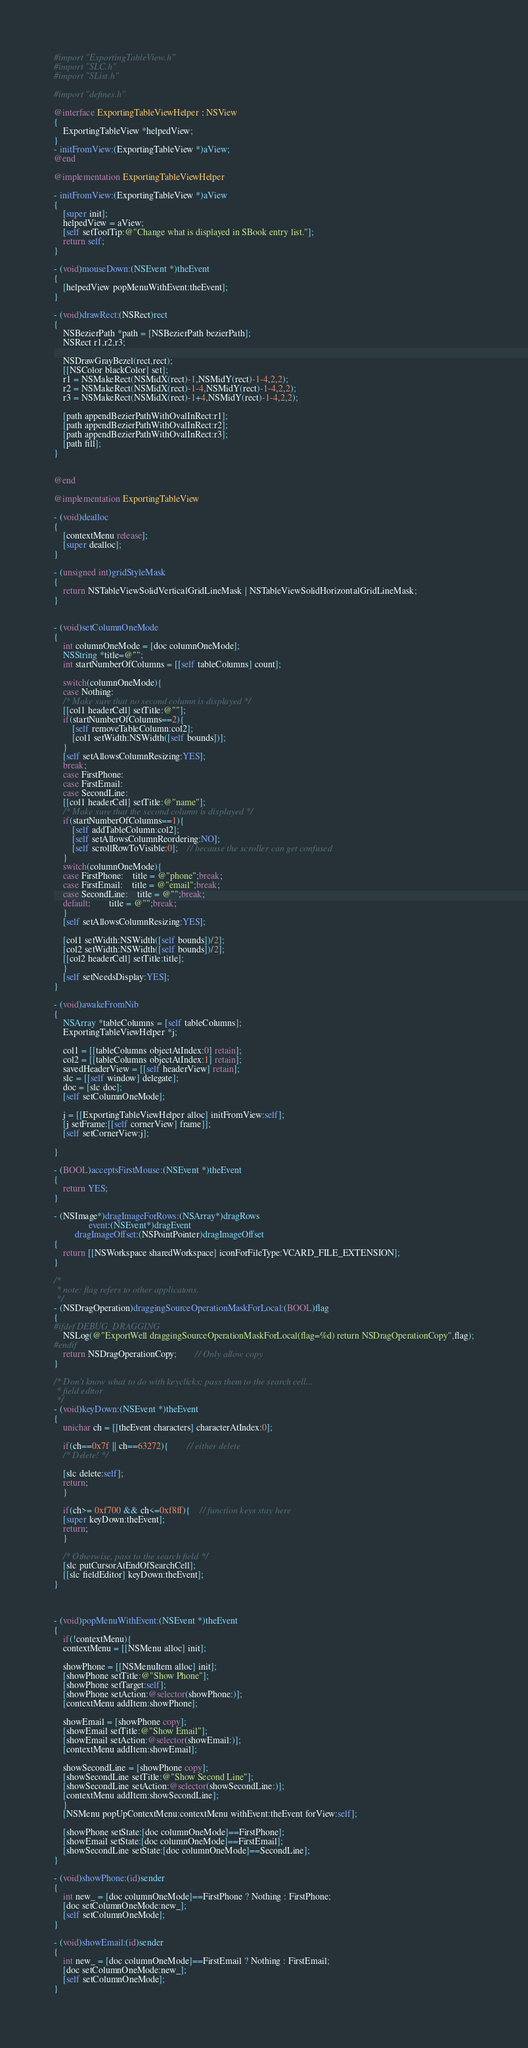<code> <loc_0><loc_0><loc_500><loc_500><_ObjectiveC_>
#import "ExportingTableView.h"
#import "SLC.h"
#import "SList.h"

#import "defines.h"

@interface ExportingTableViewHelper : NSView
{
    ExportingTableView *helpedView;
}
- initFromView:(ExportingTableView *)aView;
@end

@implementation ExportingTableViewHelper

- initFromView:(ExportingTableView *)aView
{
    [super init];
    helpedView = aView;
    [self setToolTip:@"Change what is displayed in SBook entry list."];
    return self;
}

- (void)mouseDown:(NSEvent *)theEvent
{
    [helpedView popMenuWithEvent:theEvent];
}

- (void)drawRect:(NSRect)rect
{
    NSBezierPath *path = [NSBezierPath bezierPath];
    NSRect r1,r2,r3;

    NSDrawGrayBezel(rect,rect);
    [[NSColor blackColor] set];
    r1 = NSMakeRect(NSMidX(rect)-1,NSMidY(rect)-1-4,2,2);
    r2 = NSMakeRect(NSMidX(rect)-1-4,NSMidY(rect)-1-4,2,2);
    r3 = NSMakeRect(NSMidX(rect)-1+4,NSMidY(rect)-1-4,2,2);

    [path appendBezierPathWithOvalInRect:r1];
    [path appendBezierPathWithOvalInRect:r2];
    [path appendBezierPathWithOvalInRect:r3];
    [path fill];
}


@end

@implementation ExportingTableView

- (void)dealloc
{
    [contextMenu release];
    [super dealloc];
}

- (unsigned int)gridStyleMask
{
    return NSTableViewSolidVerticalGridLineMask | NSTableViewSolidHorizontalGridLineMask;
}


- (void)setColumnOneMode
{
    int columnOneMode = [doc columnOneMode];
    NSString *title=@"";
    int startNumberOfColumns = [[self tableColumns] count];

    switch(columnOneMode){
    case Nothing:
	/* Make sure that no second column is displayed */
	[[col1 headerCell] setTitle:@""];
	if(startNumberOfColumns==2){
	    [self removeTableColumn:col2];
	    [col1 setWidth:NSWidth([self bounds])];
	}
	[self setAllowsColumnResizing:YES];
	break;
    case FirstPhone:
    case FirstEmail:
    case SecondLine:
	[[col1 headerCell] setTitle:@"name"];
	/* Make sure that the second column is displayed */
	if(startNumberOfColumns==1){
	    [self addTableColumn:col2];
	    [self setAllowsColumnReordering:NO];
	    [self scrollRowToVisible:0];	// because the scroller can get confused
	}
	switch(columnOneMode){
	case FirstPhone:	title = @"phone";break;
	case FirstEmail:	title = @"email";break;
	case SecondLine:	title = @"";break;
	default:		title = @"";break;
	}
	[self setAllowsColumnResizing:YES];

	[col1 setWidth:NSWidth([self bounds])/2];
	[col2 setWidth:NSWidth([self bounds])/2];
	[[col2 headerCell] setTitle:title];
    }
    [self setNeedsDisplay:YES];
}

- (void)awakeFromNib
{
    NSArray *tableColumns = [self tableColumns];
    ExportingTableViewHelper *j;

    col1 = [[tableColumns objectAtIndex:0] retain];
    col2 = [[tableColumns objectAtIndex:1] retain]; 
    savedHeaderView = [[self headerView] retain];
    slc = [[self window] delegate];
    doc = [slc doc];
    [self setColumnOneMode];

    j = [[ExportingTableViewHelper alloc] initFromView:self];
    [j setFrame:[[self cornerView] frame]];
    [self setCornerView:j];

}

- (BOOL)acceptsFirstMouse:(NSEvent *)theEvent
{
    return YES;
}

- (NSImage*)dragImageForRows:(NSArray*)dragRows
		       event:(NSEvent*)dragEvent
	     dragImageOffset:(NSPointPointer)dragImageOffset
{
    return [[NSWorkspace sharedWorkspace] iconForFileType:VCARD_FILE_EXTENSION];
}

/*
 * note: flag refers to other applicatons.
 */
- (NSDragOperation)draggingSourceOperationMaskForLocal:(BOOL)flag
{
#ifdef DEBUG_DRAGGING
    NSLog(@"ExportWell draggingSourceOperationMaskForLocal(flag=%d) return NSDragOperationCopy",flag);
#endif    
    return NSDragOperationCopy;		// Only allow copy
}

/* Don't know what to do with keyclicks; pass them to the search cell...
 * field editor
 */
- (void)keyDown:(NSEvent *)theEvent
{
    unichar ch = [[theEvent characters] characterAtIndex:0];

    if(ch==0x7f || ch==63272){		// either delete
	/* Delete! */
	
	[slc delete:self];
	return;
    }

    if(ch>= 0xf700 && ch<=0xf8ff){	// function keys stay here
	[super keyDown:theEvent];
	return;
    }

    /* Otherwise, pass to the search field */
    [slc putCursorAtEndOfSearchCell];
    [[slc fieldEditor] keyDown:theEvent];
}



- (void)popMenuWithEvent:(NSEvent *)theEvent
{
    if(!contextMenu){
	contextMenu = [[NSMenu alloc] init];

	showPhone = [[NSMenuItem alloc] init];
	[showPhone setTitle:@"Show Phone"];
	[showPhone setTarget:self];
	[showPhone setAction:@selector(showPhone:)];
	[contextMenu addItem:showPhone];

	showEmail = [showPhone copy];
	[showEmail setTitle:@"Show Email"];
	[showEmail setAction:@selector(showEmail:)];
	[contextMenu addItem:showEmail];

	showSecondLine = [showPhone copy];
	[showSecondLine setTitle:@"Show Second Line"];
	[showSecondLine setAction:@selector(showSecondLine:)];
	[contextMenu addItem:showSecondLine];
    }
    [NSMenu popUpContextMenu:contextMenu withEvent:theEvent forView:self];

    [showPhone setState:[doc columnOneMode]==FirstPhone];
    [showEmail setState:[doc columnOneMode]==FirstEmail];
    [showSecondLine setState:[doc columnOneMode]==SecondLine];
}

- (void)showPhone:(id)sender
{
    int new_ = [doc columnOneMode]==FirstPhone ? Nothing : FirstPhone;
    [doc setColumnOneMode:new_];
    [self setColumnOneMode];
}

- (void)showEmail:(id)sender
{
    int new_ = [doc columnOneMode]==FirstEmail ? Nothing : FirstEmail;
    [doc setColumnOneMode:new_];
    [self setColumnOneMode];
}
</code> 